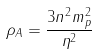<formula> <loc_0><loc_0><loc_500><loc_500>\rho _ { A } = \frac { 3 n ^ { 2 } m _ { p } ^ { 2 } } { \eta ^ { 2 } }</formula> 